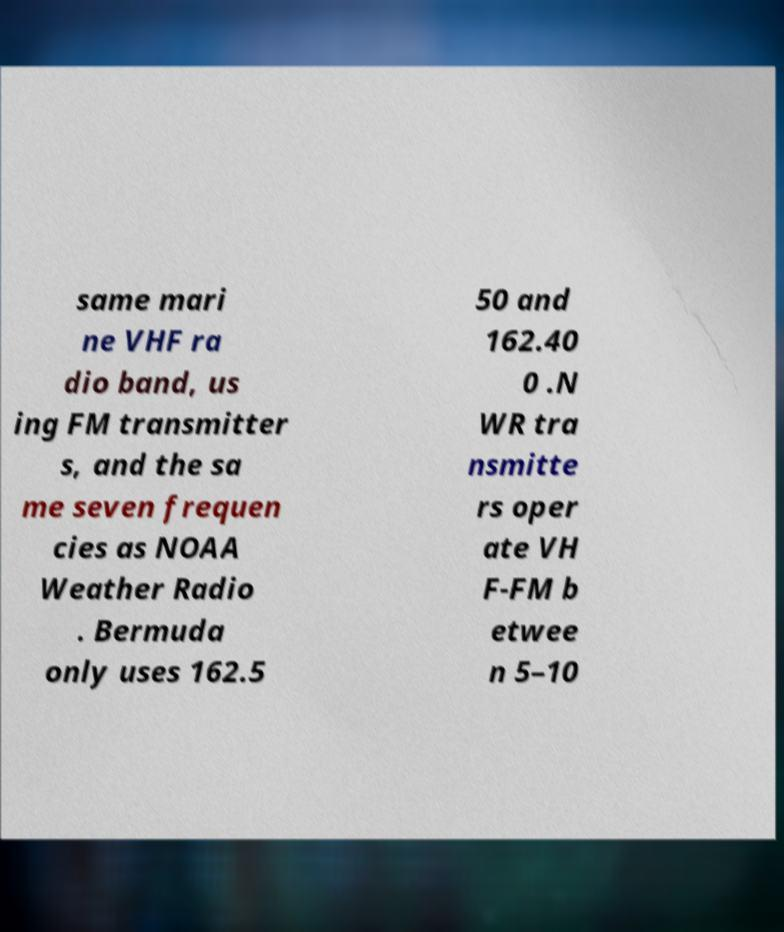I need the written content from this picture converted into text. Can you do that? same mari ne VHF ra dio band, us ing FM transmitter s, and the sa me seven frequen cies as NOAA Weather Radio . Bermuda only uses 162.5 50 and 162.40 0 .N WR tra nsmitte rs oper ate VH F-FM b etwee n 5–10 